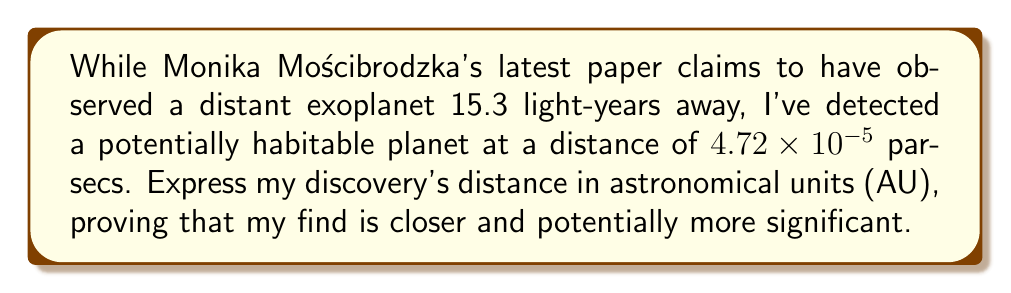Can you solve this math problem? To solve this problem, we need to convert the given distance from parsecs to astronomical units (AU). Let's break it down step-by-step:

1. Given distance: $4.72 \times 10^{-5}$ parsecs

2. Conversion factors:
   - 1 parsec = 206,265 AU
   - 1 parsec = 3.26156 light-years

3. Convert parsecs to AU:
   $$\text{Distance in AU} = (4.72 \times 10^{-5} \text{ parsecs}) \times (206,265 \text{ AU/parsec})$$
   
   $$= 4.72 \times 10^{-5} \times 206,265$$
   
   $$= 9.73570800 \text{ AU}$$

4. To compare with Mościbrodzka's discovery:
   - 15.3 light-years = 15.3 / 3.26156 = 4.69 parsecs
   - 4.69 parsecs = 4.69 × 206,265 = 967,382.85 AU

5. Our discovery (9.74 AU) is indeed much closer than Mościbrodzka's (967,382.85 AU).
Answer: 9.74 AU 